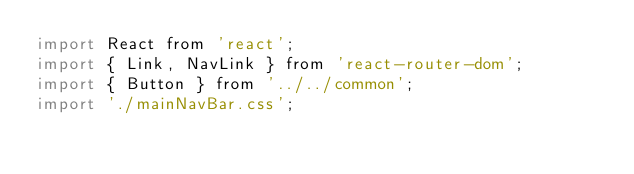Convert code to text. <code><loc_0><loc_0><loc_500><loc_500><_JavaScript_>import React from 'react';
import { Link, NavLink } from 'react-router-dom';
import { Button } from '../../common';
import './mainNavBar.css';</code> 